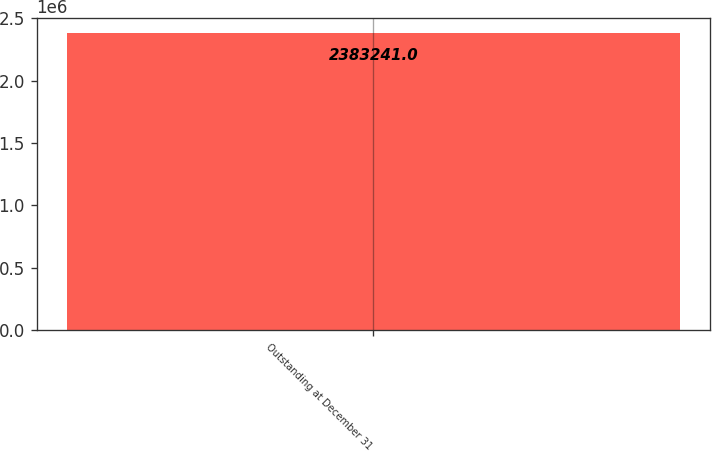Convert chart. <chart><loc_0><loc_0><loc_500><loc_500><bar_chart><fcel>Outstanding at December 31<nl><fcel>2.38324e+06<nl></chart> 